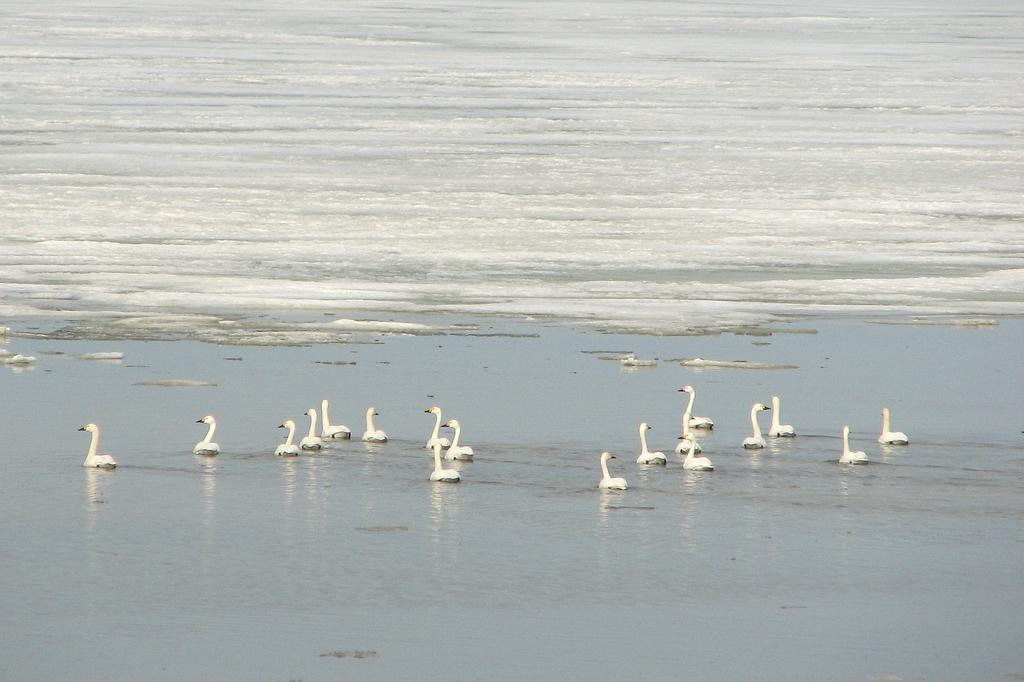What animals can be seen in the image? There are ducks in the image. What are the ducks doing in the image? The ducks are swimming in the image. What type of water is present in the image? There is water (ocean) in the image. What natural phenomenon can be observed in the water? There are tides in the water. What type of knot is being used to secure the ducks in the image? There is no knot present in the image, as the ducks are swimming freely in the water. 